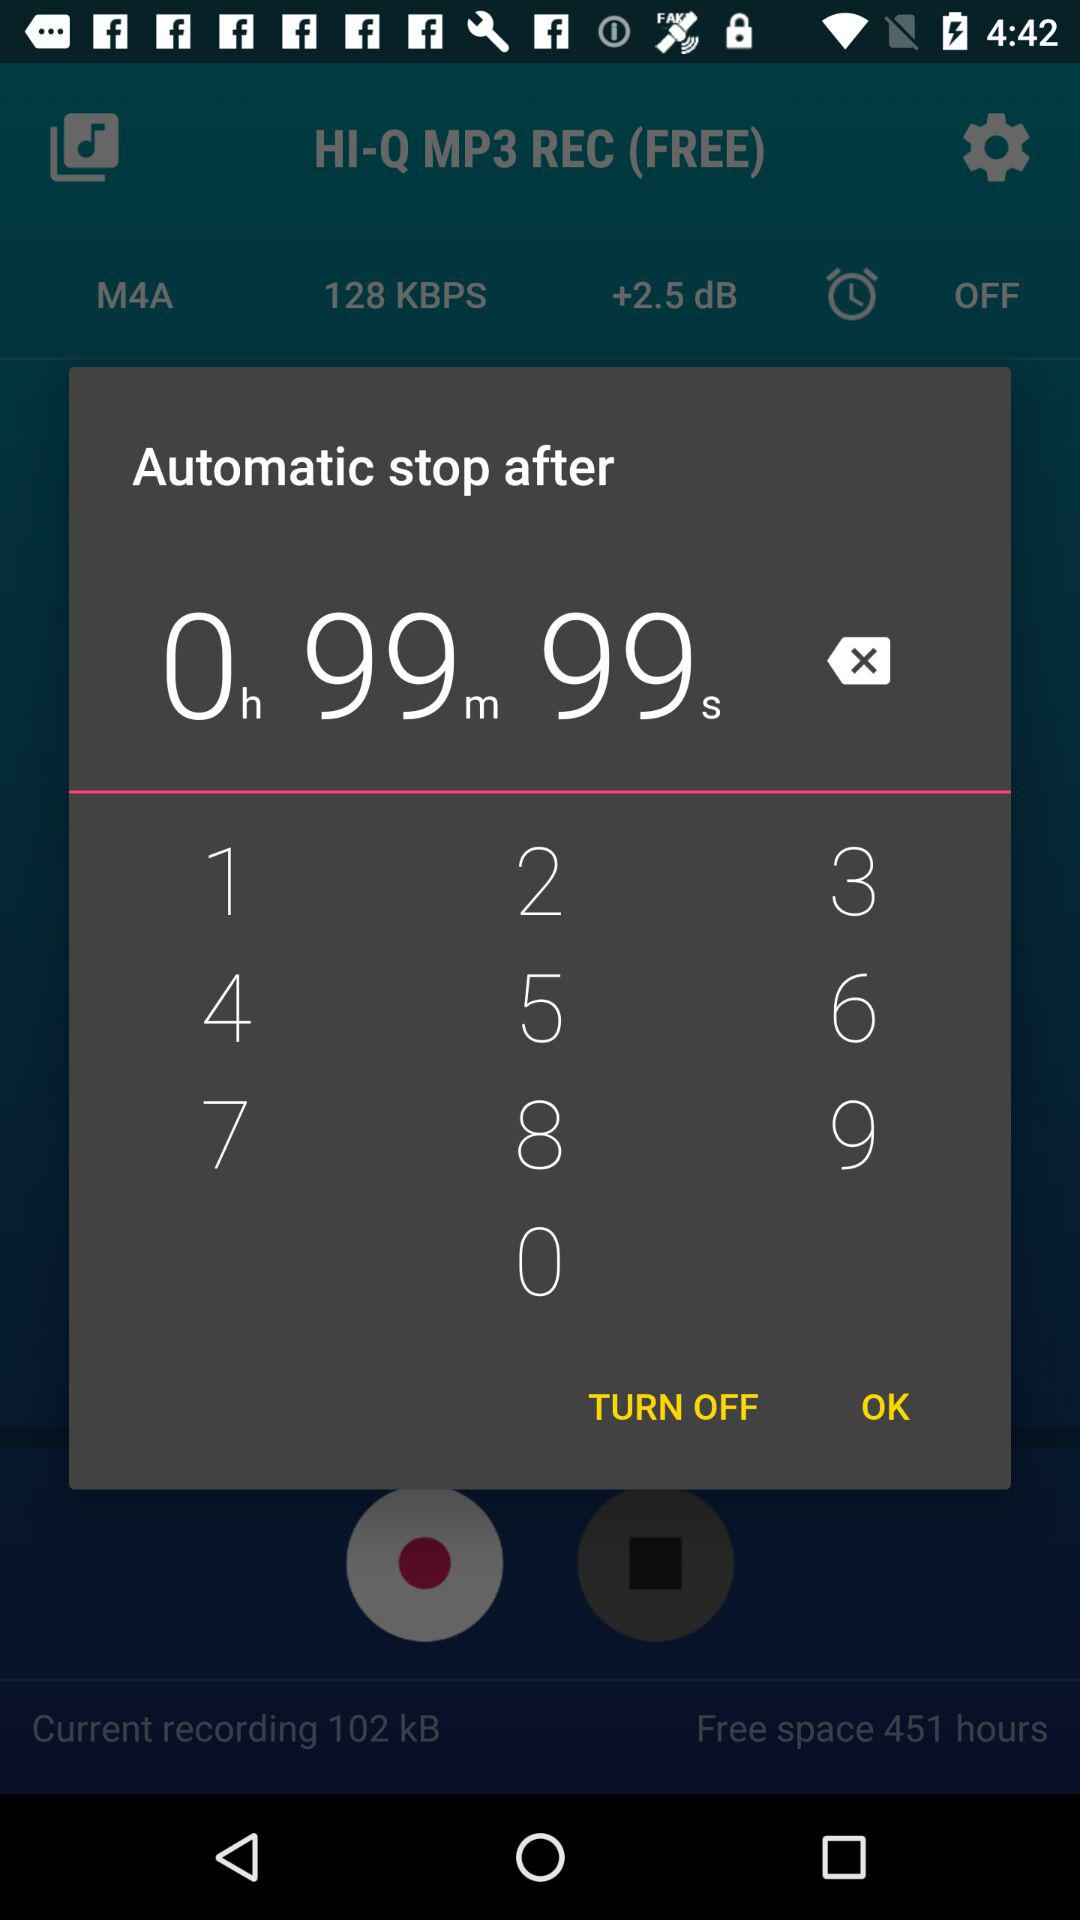Automatic stop time after how many seconds? After 99 seconds, the time automatically stops. 